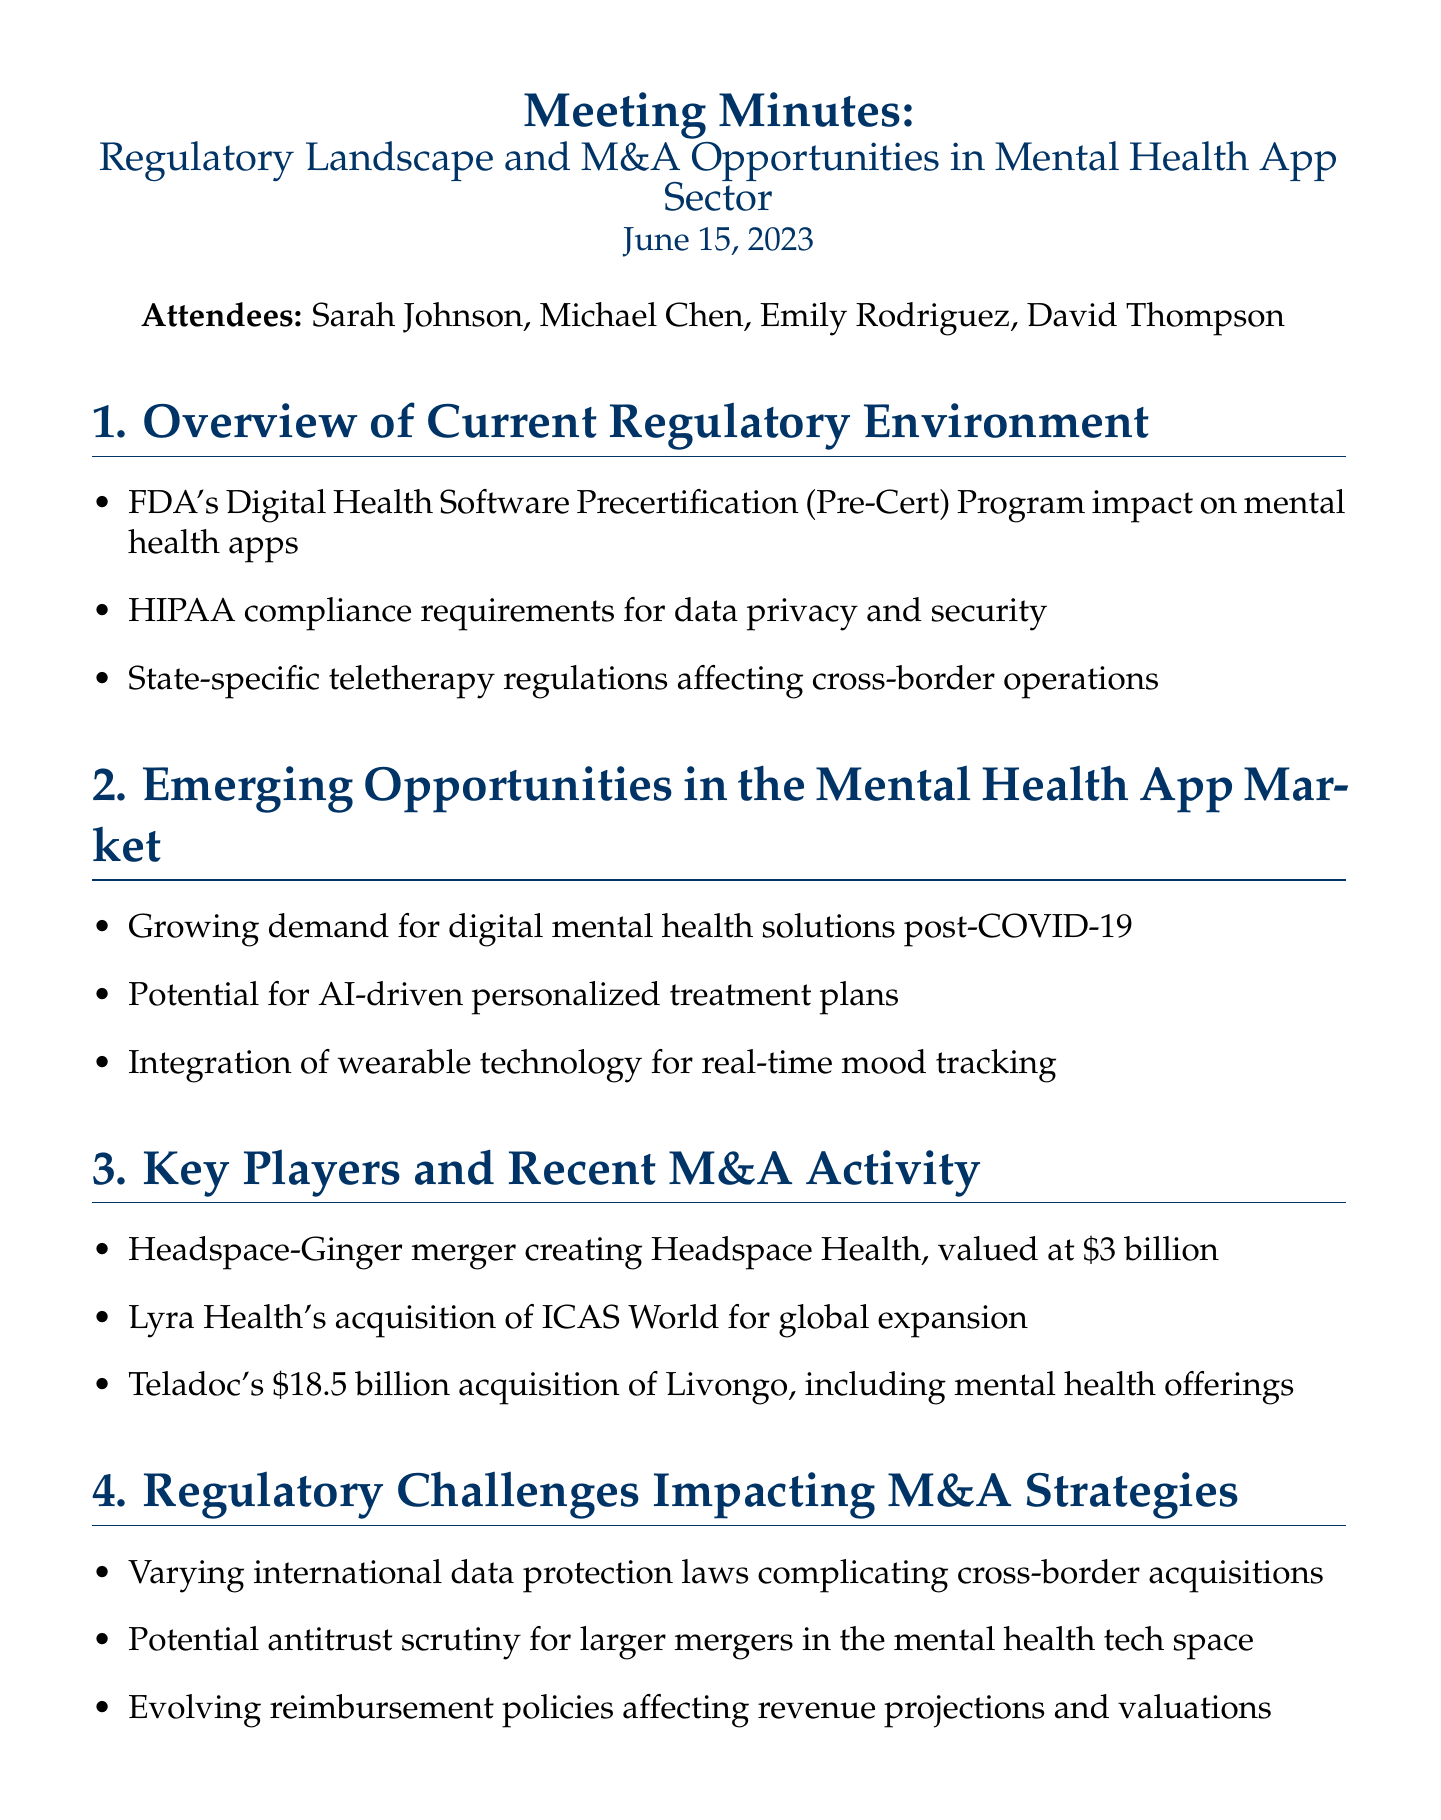What is the date of the meeting? The date of the meeting is stated clearly in the document.
Answer: June 15, 2023 Who is the founder of a mental health startup that attended the meeting? The document lists attendees, including the founder of a mental health startup.
Answer: Emily Rodriguez What merger is valued at $3 billion? The document specifies a merger that resulted in a substantial valuation.
Answer: Headspace-Ginger What is one regulatory challenge mentioned affecting M&A strategies? The document lists several challenges impacting merger and acquisition strategies.
Answer: Varying international data protection laws Which program impacts mental health apps according to the meeting? The document identifies a specific program that has implications for mental health applications.
Answer: FDA's Digital Health Software Precertification (Pre-Cert) Program What is one recommendation for the future outlook? The document outlines several recommendations based on the discussed topics.
Answer: Increased focus on evidence-based outcomes What was the purpose of exploring partnerships with RegTech firms? The document highlights a specific action item related to regulatory technology.
Answer: To navigate complex regulations Which acquisition aimed at global expansion? The document provides details on a recent acquisition related to this goal.
Answer: Lyra Health's acquisition of ICAS World 